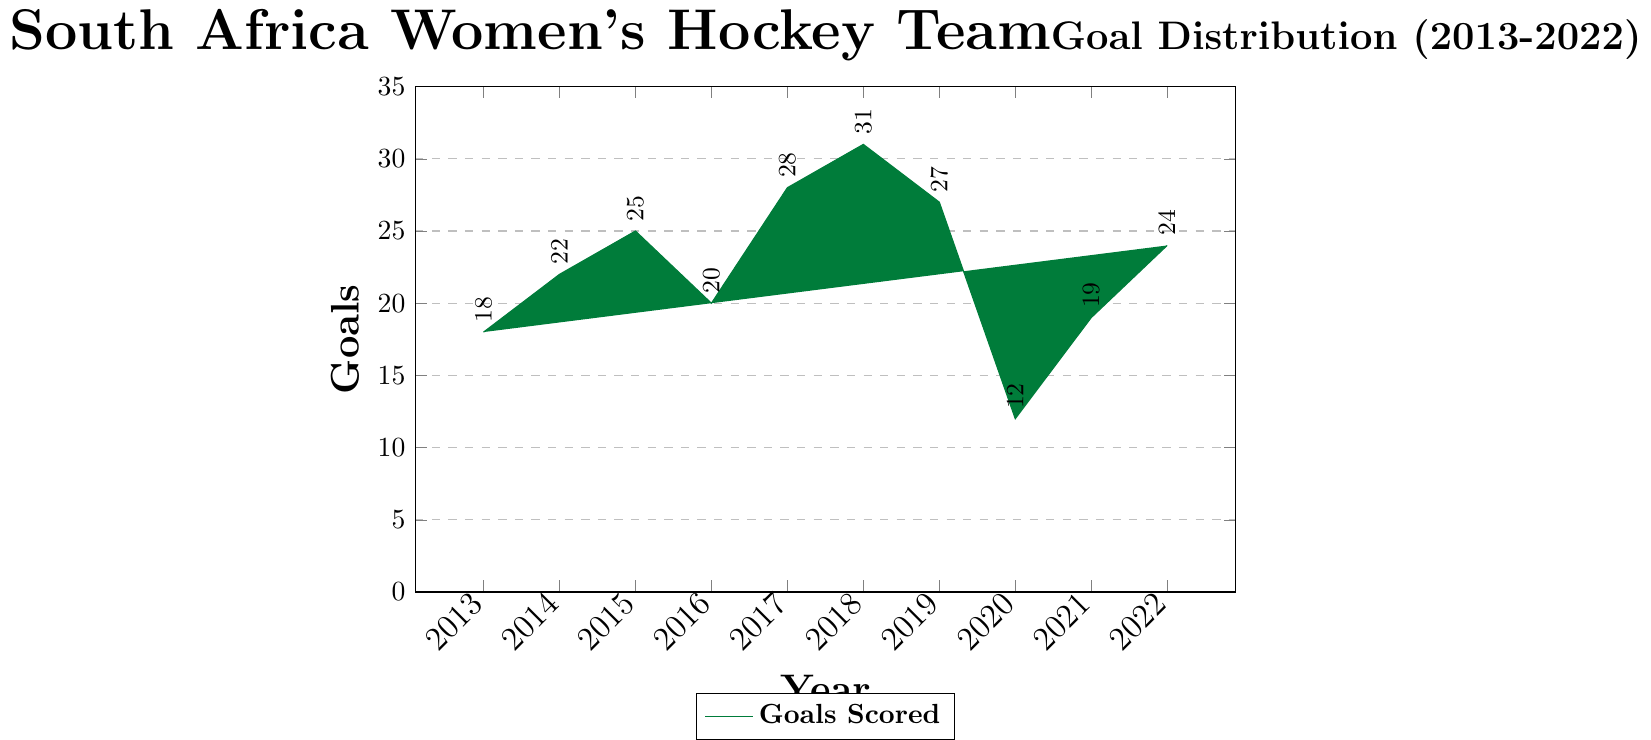What was the highest number of goals scored in a single year? By examining the height of the bars, the highest bar corresponds to the year 2018 with 31 goals.
Answer: 31 In which year did the South Africa women's hockey team score the fewest goals? The shortest bar corresponds to the year 2020 with 12 goals.
Answer: 2020 What is the total number of goals scored between 2015 and 2019 inclusive? Sum the goals for the years 2015, 2016, 2017, 2018, and 2019: 25 + 20 + 28 + 31 + 27 = 131
Answer: 131 What's the average number of goals scored per year over the decade? Add all the goals from 2013 to 2022 and divide by 10: (18 + 22 + 25 + 20 + 28 + 31 + 27 + 12 + 19 + 24) / 10 = 226 / 10 = 22.6
Answer: 22.6 What is the range of goals scored in the decade? Subtract the lowest number of goals scored (12 in 2020) from the highest (31 in 2018): 31 - 12 = 19
Answer: 19 Compared to 2016, did the team score more or fewer goals in 2021? By how many? In 2016, the team scored 20 goals; in 2021, they scored 19. The difference is 20 - 19 = 1 fewer goal in 2021.
Answer: 1 fewer How many years saw more than 25 goals scored? Count the bars that reach above the 25-goal mark: 2017 (28), 2018 (31), 2019 (27), and 2022 (24). Only 2017, 2018, and 2019 are above 25, totaling 3 years.
Answer: 3 Which year experienced the largest increase in goals from the previous year? Calculate the year-over-year increases and identify the largest: 2014 (22-18=4), 2015 (25-22=3), 2016 (20-25=-5), 2017 (28-20=8), 2018 (31-28=3), 2019 (27-31=-4), 2020 (12-27=-15), 2021 (19-12=7), 2022 (24-19=5). The largest increase is from 2016 to 2017 with 8 goals.
Answer: 2017 Did the team score more goals in the first half (2013-2017) or the second half (2018-2022) of the decade? Sum the goals for 2013-2017: 18 + 22 + 25 + 20 + 28 = 113. Sum the goals for 2018-2022: 31 + 27 + 12 + 19 + 24 = 113. Both halves have the same total, 113.
Answer: Both halves are equal What was the median number of goals scored in a year? Arrange the numbers in ascending order and find the median value: 12, 18, 19, 20, 22, 24, 25, 27, 28, 31. The median is the average of the 5th and 6th values: (22 + 24)/2 = 23
Answer: 23 